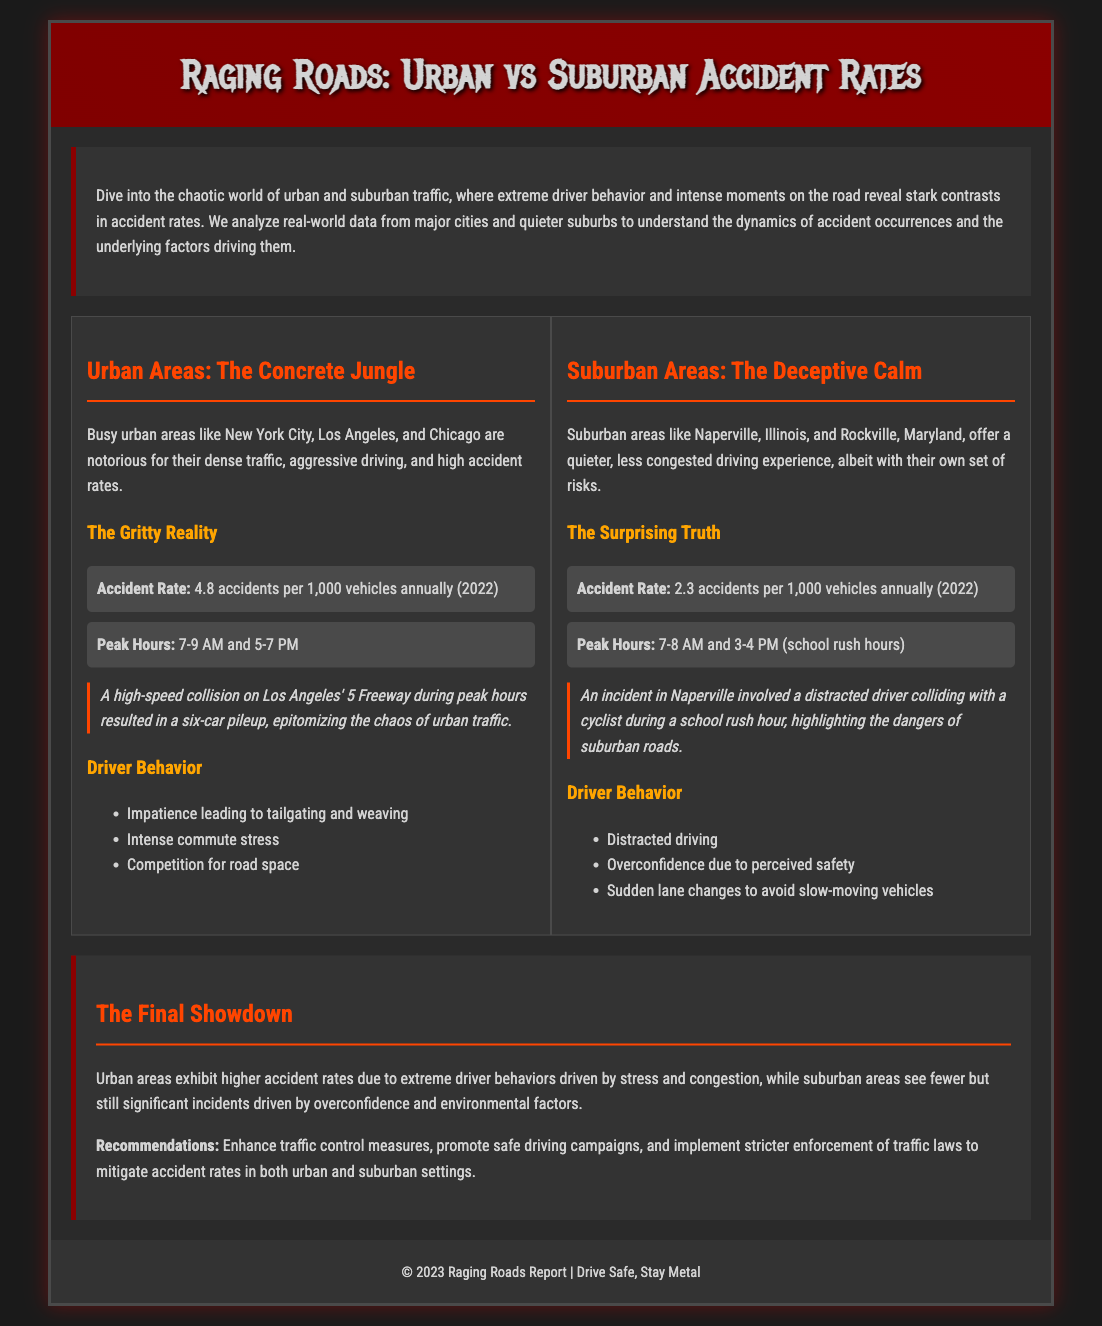What is the accident rate in urban areas? The accident rate in urban areas is stated as 4.8 accidents per 1,000 vehicles annually in the document.
Answer: 4.8 accidents per 1,000 vehicles annually What is the accident rate in suburban areas? The accident rate in suburban areas is mentioned as 2.3 accidents per 1,000 vehicles annually.
Answer: 2.3 accidents per 1,000 vehicles annually What are the peak hours for urban areas? The document specifies peak hours for urban areas as 7-9 AM and 5-7 PM.
Answer: 7-9 AM and 5-7 PM What behavior is common among urban drivers? The document lists impatience leading to tailgating and weaving as a common behavior among urban drivers.
Answer: Impatience leading to tailgating and weaving What notable case occurred in suburban areas? The document describes an incident in Naperville involving a distracted driver colliding with a cyclist.
Answer: Distracted driver colliding with a cyclist Which area has a lower accident rate? A comparison in the document shows suburban areas have a lower accident rate than urban areas.
Answer: Suburban areas What is a recommended measure to mitigate accident rates? The document suggests enhancing traffic control measures as a recommendation to mitigate accident rates.
Answer: Enhance traffic control measures What time is peak school rush hour in suburban areas? The document states that peak school rush hour in suburban areas is 7-8 AM and 3-4 PM.
Answer: 7-8 AM and 3-4 PM Which urban area is mentioned in the document as busy? The document specifically mentions Los Angeles as a busy urban area.
Answer: Los Angeles 